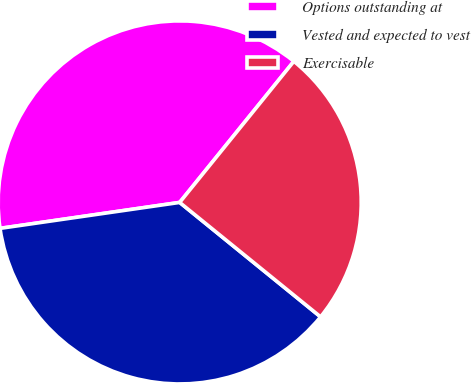Convert chart. <chart><loc_0><loc_0><loc_500><loc_500><pie_chart><fcel>Options outstanding at<fcel>Vested and expected to vest<fcel>Exercisable<nl><fcel>38.11%<fcel>36.86%<fcel>25.03%<nl></chart> 